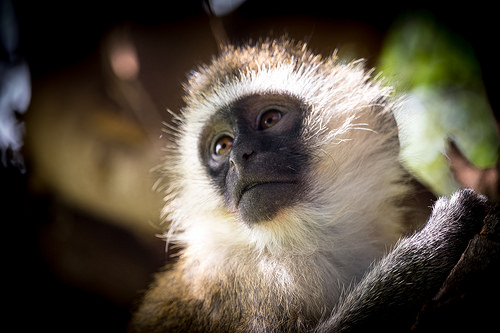<image>
Can you confirm if the monkey is under the head? No. The monkey is not positioned under the head. The vertical relationship between these objects is different. 